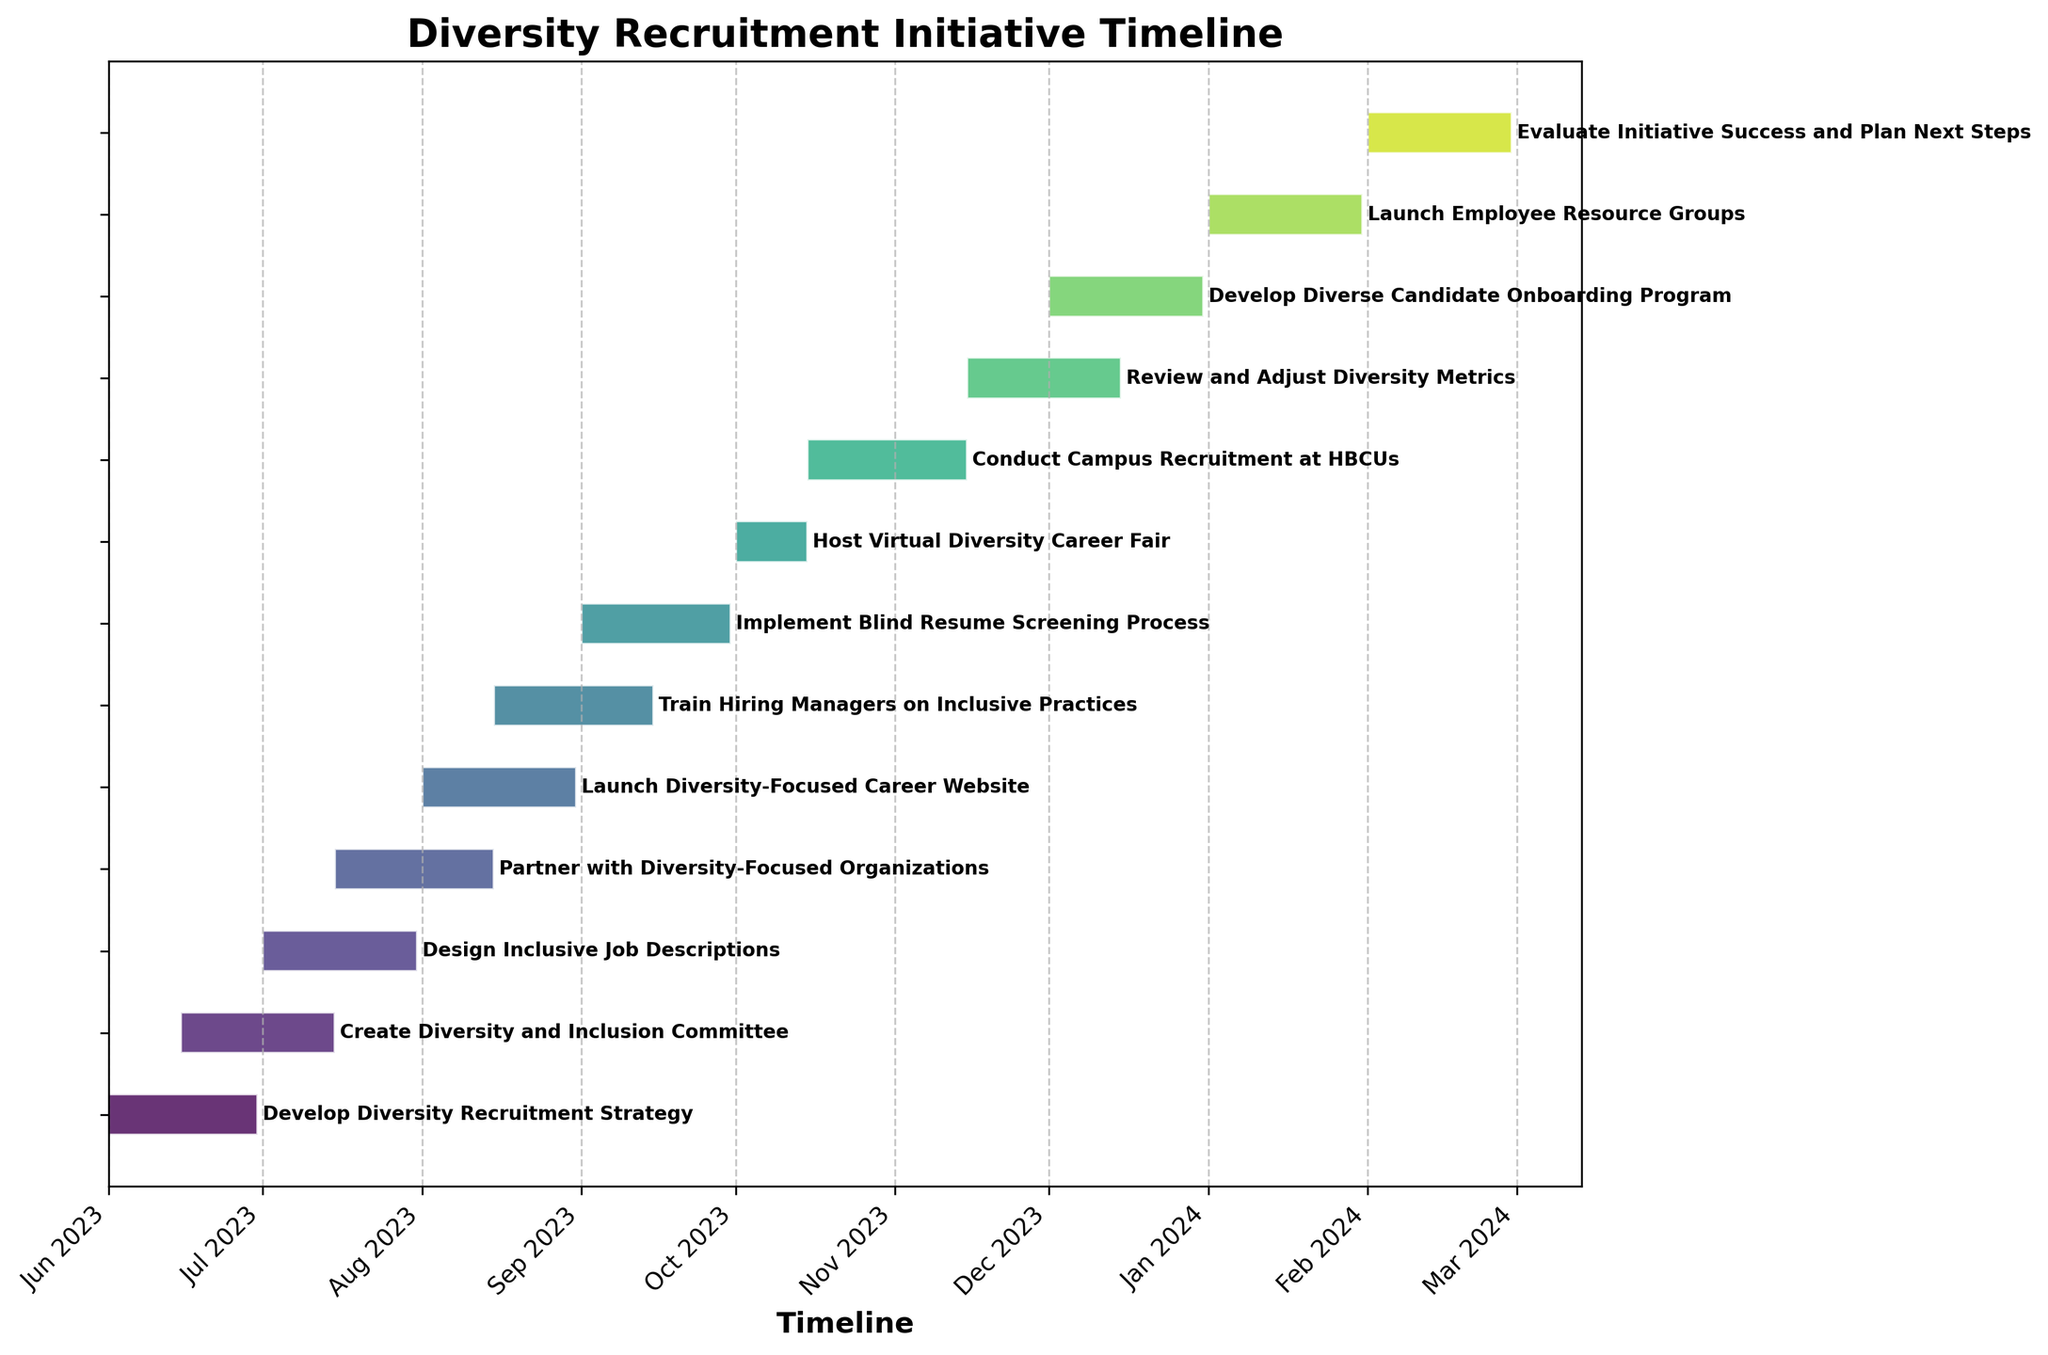What is the title of the chart? The title is located at the top of the chart and is usually in a larger, bold font.
Answer: Diversity Recruitment Initiative Timeline What is the duration of the "Train Hiring Managers on Inclusive Practices" stage? Locate the "Train Hiring Managers on Inclusive Practices" task, note its Start Date (2023-08-15) and End Date (2023-09-15), and calculate the difference between these dates.
Answer: 31 days Which task starts first? Identify the tasks and compare their Start Dates. The task with the earliest Start Date starts first.
Answer: Develop Diversity Recruitment Strategy How many tasks are there in total? Count the number of horizontal bars, as each bar represents a task.
Answer: 12 Which two tasks are ongoing in July 2023? Examine the bars corresponding to July 2023 and identify which tasks span across this month.
Answer: Create Diversity and Inclusion Committee, Design Inclusive Job Descriptions Which task has the longest duration? Compare the lengths of the horizontal bars, as longer bars represent tasks with longer durations.
Answer: Review and Adjust Diversity Metrics How many tasks are scheduled to end in December 2023? Look for the tasks with End Dates within December 2023.
Answer: 2 What are the start and end dates for the "Host Virtual Diversity Career Fair" task? Locate the task "Host Virtual Diversity Career Fair" and note down its Start Date (2023-10-01) and End Date (2023-10-15).
Answer: 2023-10-01 to 2023-10-15 How many tasks involve activities related to recruitment events? Identify tasks that explicitly mention recruitment events, such as fairs or campus recruitment.
Answer: 2 Which task is the final one in the timeline? Look at the end of the chart and identify the last bar, which represents the final task.
Answer: Evaluate Initiative Success and Plan Next Steps 